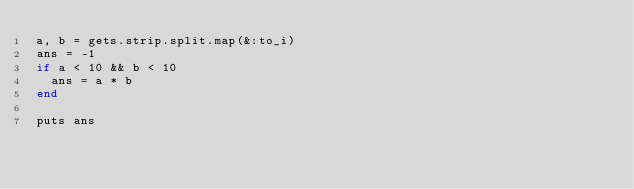<code> <loc_0><loc_0><loc_500><loc_500><_Ruby_>a, b = gets.strip.split.map(&:to_i)
ans = -1
if a < 10 && b < 10
  ans = a * b
end

puts ans</code> 